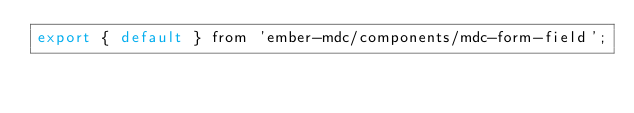<code> <loc_0><loc_0><loc_500><loc_500><_JavaScript_>export { default } from 'ember-mdc/components/mdc-form-field';
</code> 